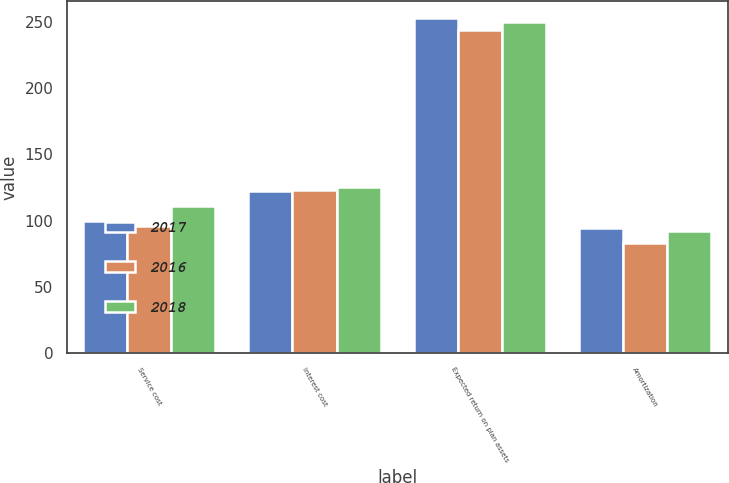<chart> <loc_0><loc_0><loc_500><loc_500><stacked_bar_chart><ecel><fcel>Service cost<fcel>Interest cost<fcel>Expected return on plan assets<fcel>Amortization<nl><fcel>2017<fcel>100<fcel>122<fcel>253<fcel>94<nl><fcel>2016<fcel>96<fcel>123<fcel>244<fcel>83<nl><fcel>2018<fcel>111<fcel>125<fcel>250<fcel>92<nl></chart> 